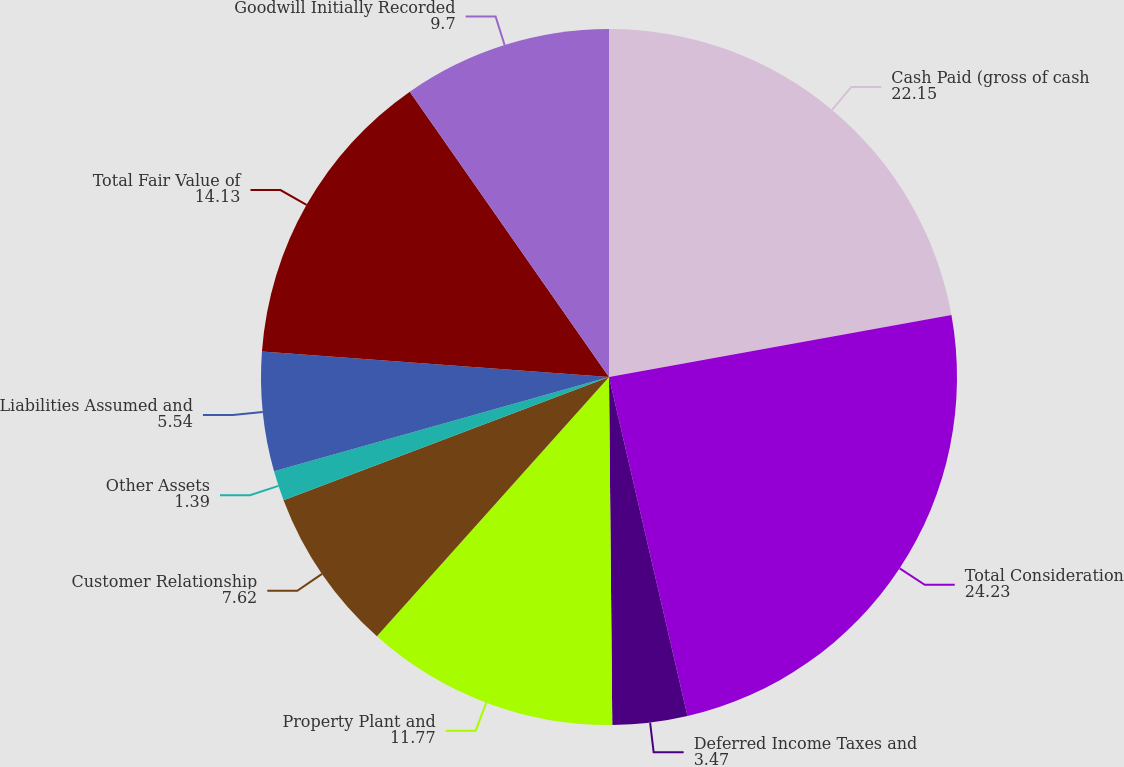Convert chart to OTSL. <chart><loc_0><loc_0><loc_500><loc_500><pie_chart><fcel>Cash Paid (gross of cash<fcel>Total Consideration<fcel>Deferred Income Taxes and<fcel>Property Plant and<fcel>Customer Relationship<fcel>Other Assets<fcel>Liabilities Assumed and<fcel>Total Fair Value of<fcel>Goodwill Initially Recorded<nl><fcel>22.15%<fcel>24.23%<fcel>3.47%<fcel>11.77%<fcel>7.62%<fcel>1.39%<fcel>5.54%<fcel>14.13%<fcel>9.7%<nl></chart> 